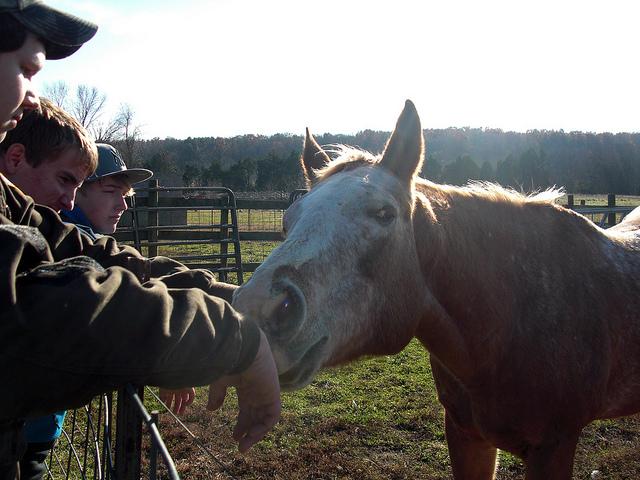How many eyes are shown?
Be succinct. 4. Which man is hat-less?
Answer briefly. Middle. Is the man wearing a jacket?
Give a very brief answer. Yes. 